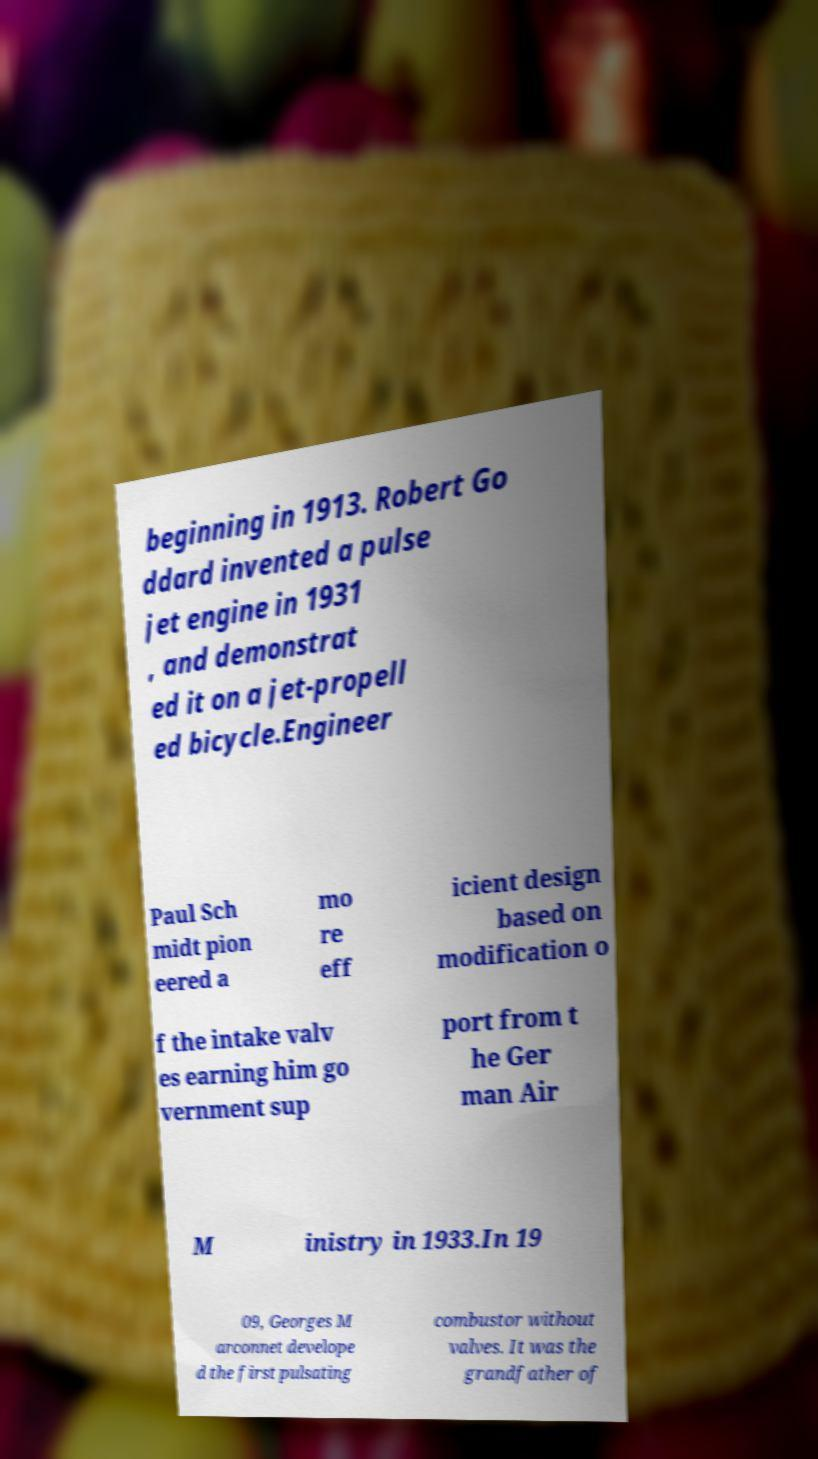For documentation purposes, I need the text within this image transcribed. Could you provide that? beginning in 1913. Robert Go ddard invented a pulse jet engine in 1931 , and demonstrat ed it on a jet-propell ed bicycle.Engineer Paul Sch midt pion eered a mo re eff icient design based on modification o f the intake valv es earning him go vernment sup port from t he Ger man Air M inistry in 1933.In 19 09, Georges M arconnet develope d the first pulsating combustor without valves. It was the grandfather of 